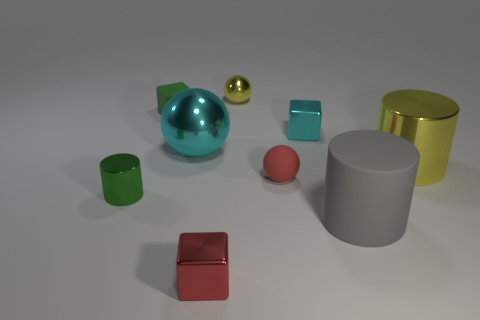Subtract all tiny rubber cubes. How many cubes are left? 2 Subtract 1 cylinders. How many cylinders are left? 2 Add 1 red things. How many objects exist? 10 Subtract all balls. How many objects are left? 6 Subtract all cylinders. Subtract all large metal things. How many objects are left? 4 Add 8 small red shiny objects. How many small red shiny objects are left? 9 Add 8 small yellow blocks. How many small yellow blocks exist? 8 Subtract 0 purple blocks. How many objects are left? 9 